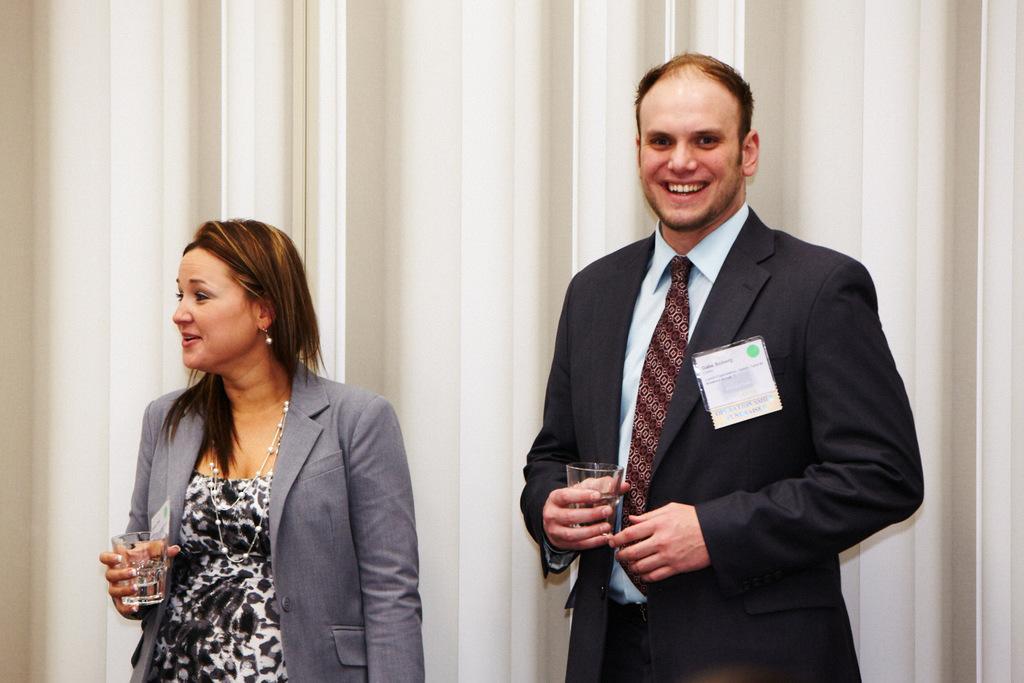In one or two sentences, can you explain what this image depicts? In this image, we can see a man and a lady standing and smiling and holding glasses in their hands. In the background, there is a curtain. 